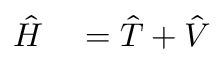<formula> <loc_0><loc_0><loc_500><loc_500>\begin{array} { r l } { { \hat { H } } } & = { \hat { T } } + { \hat { V } } } \end{array}</formula> 